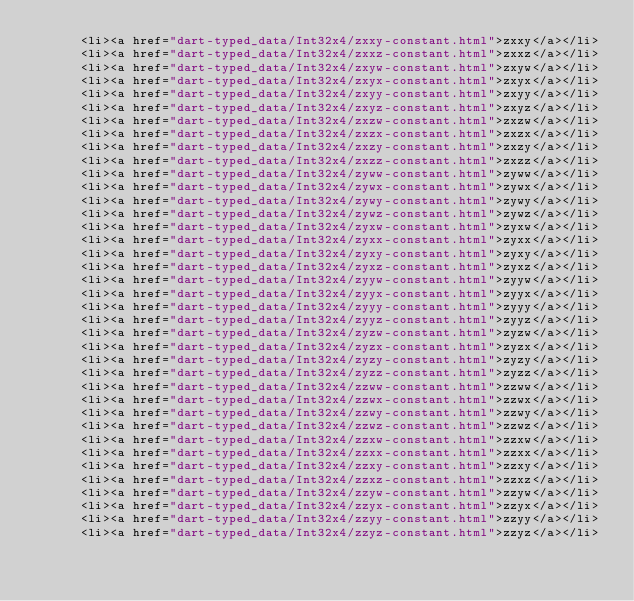<code> <loc_0><loc_0><loc_500><loc_500><_HTML_>      <li><a href="dart-typed_data/Int32x4/zxxy-constant.html">zxxy</a></li>
      <li><a href="dart-typed_data/Int32x4/zxxz-constant.html">zxxz</a></li>
      <li><a href="dart-typed_data/Int32x4/zxyw-constant.html">zxyw</a></li>
      <li><a href="dart-typed_data/Int32x4/zxyx-constant.html">zxyx</a></li>
      <li><a href="dart-typed_data/Int32x4/zxyy-constant.html">zxyy</a></li>
      <li><a href="dart-typed_data/Int32x4/zxyz-constant.html">zxyz</a></li>
      <li><a href="dart-typed_data/Int32x4/zxzw-constant.html">zxzw</a></li>
      <li><a href="dart-typed_data/Int32x4/zxzx-constant.html">zxzx</a></li>
      <li><a href="dart-typed_data/Int32x4/zxzy-constant.html">zxzy</a></li>
      <li><a href="dart-typed_data/Int32x4/zxzz-constant.html">zxzz</a></li>
      <li><a href="dart-typed_data/Int32x4/zyww-constant.html">zyww</a></li>
      <li><a href="dart-typed_data/Int32x4/zywx-constant.html">zywx</a></li>
      <li><a href="dart-typed_data/Int32x4/zywy-constant.html">zywy</a></li>
      <li><a href="dart-typed_data/Int32x4/zywz-constant.html">zywz</a></li>
      <li><a href="dart-typed_data/Int32x4/zyxw-constant.html">zyxw</a></li>
      <li><a href="dart-typed_data/Int32x4/zyxx-constant.html">zyxx</a></li>
      <li><a href="dart-typed_data/Int32x4/zyxy-constant.html">zyxy</a></li>
      <li><a href="dart-typed_data/Int32x4/zyxz-constant.html">zyxz</a></li>
      <li><a href="dart-typed_data/Int32x4/zyyw-constant.html">zyyw</a></li>
      <li><a href="dart-typed_data/Int32x4/zyyx-constant.html">zyyx</a></li>
      <li><a href="dart-typed_data/Int32x4/zyyy-constant.html">zyyy</a></li>
      <li><a href="dart-typed_data/Int32x4/zyyz-constant.html">zyyz</a></li>
      <li><a href="dart-typed_data/Int32x4/zyzw-constant.html">zyzw</a></li>
      <li><a href="dart-typed_data/Int32x4/zyzx-constant.html">zyzx</a></li>
      <li><a href="dart-typed_data/Int32x4/zyzy-constant.html">zyzy</a></li>
      <li><a href="dart-typed_data/Int32x4/zyzz-constant.html">zyzz</a></li>
      <li><a href="dart-typed_data/Int32x4/zzww-constant.html">zzww</a></li>
      <li><a href="dart-typed_data/Int32x4/zzwx-constant.html">zzwx</a></li>
      <li><a href="dart-typed_data/Int32x4/zzwy-constant.html">zzwy</a></li>
      <li><a href="dart-typed_data/Int32x4/zzwz-constant.html">zzwz</a></li>
      <li><a href="dart-typed_data/Int32x4/zzxw-constant.html">zzxw</a></li>
      <li><a href="dart-typed_data/Int32x4/zzxx-constant.html">zzxx</a></li>
      <li><a href="dart-typed_data/Int32x4/zzxy-constant.html">zzxy</a></li>
      <li><a href="dart-typed_data/Int32x4/zzxz-constant.html">zzxz</a></li>
      <li><a href="dart-typed_data/Int32x4/zzyw-constant.html">zzyw</a></li>
      <li><a href="dart-typed_data/Int32x4/zzyx-constant.html">zzyx</a></li>
      <li><a href="dart-typed_data/Int32x4/zzyy-constant.html">zzyy</a></li>
      <li><a href="dart-typed_data/Int32x4/zzyz-constant.html">zzyz</a></li></code> 